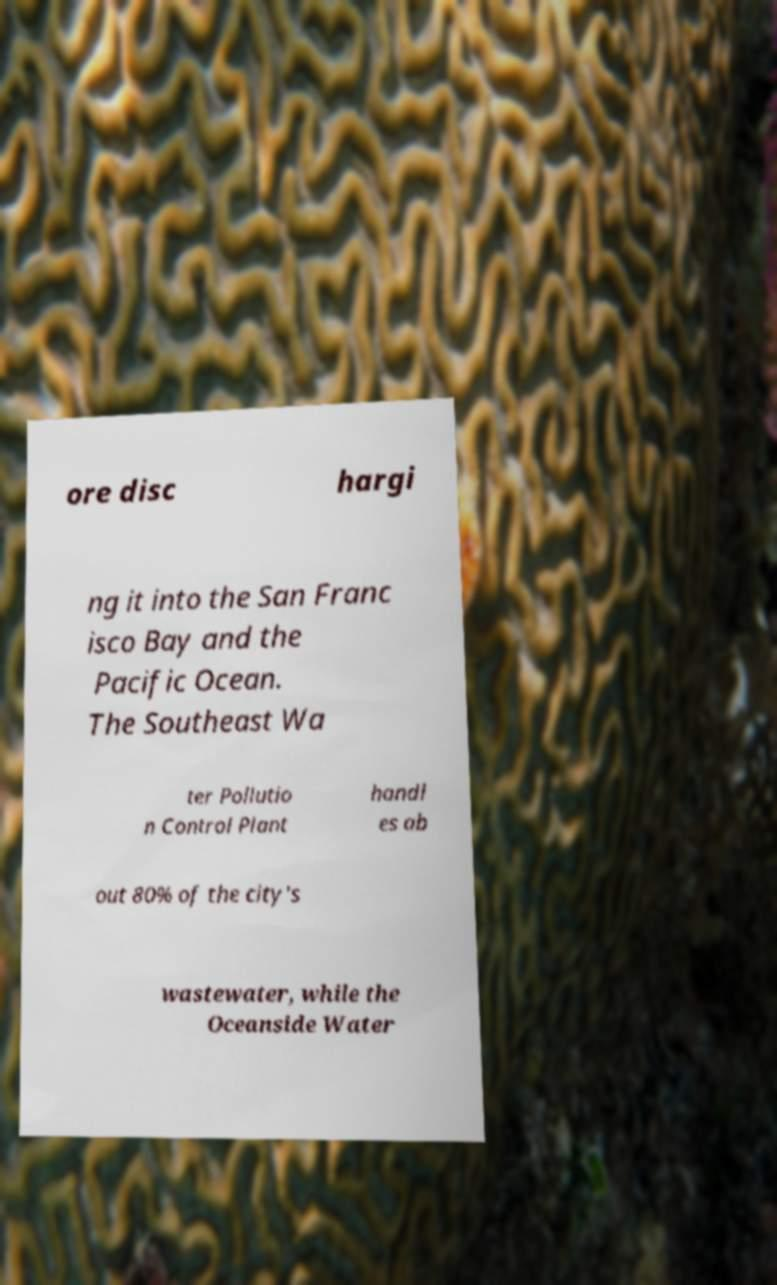I need the written content from this picture converted into text. Can you do that? ore disc hargi ng it into the San Franc isco Bay and the Pacific Ocean. The Southeast Wa ter Pollutio n Control Plant handl es ab out 80% of the city's wastewater, while the Oceanside Water 